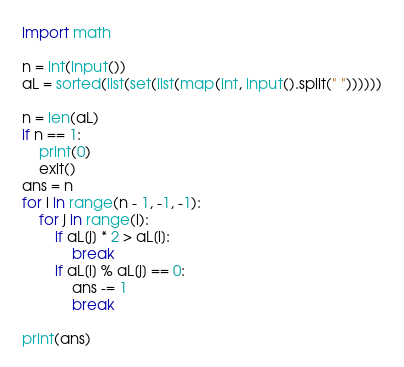Convert code to text. <code><loc_0><loc_0><loc_500><loc_500><_Python_>import math

n = int(input())
aL = sorted(list(set(list(map(int, input().split(" "))))))

n = len(aL)
if n == 1:
    print(0)
    exit()
ans = n
for i in range(n - 1, -1, -1):
    for j in range(i):
        if aL[j] * 2 > aL[i]:
            break
        if aL[i] % aL[j] == 0:
            ans -= 1
            break

print(ans)
</code> 